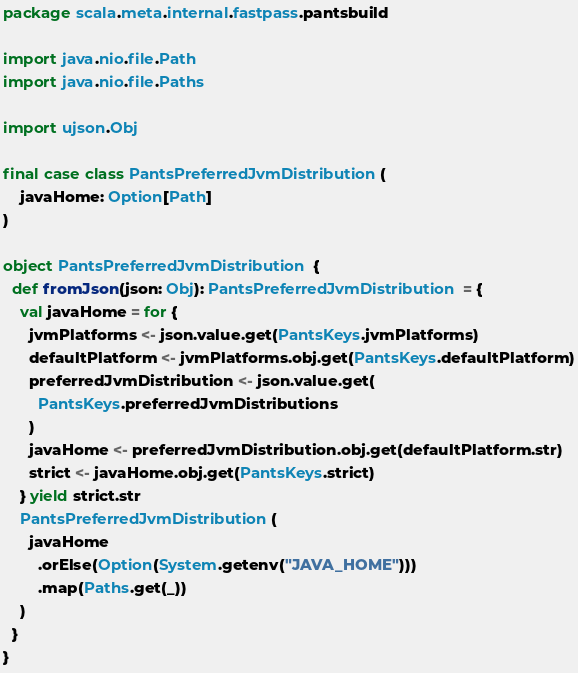<code> <loc_0><loc_0><loc_500><loc_500><_Scala_>package scala.meta.internal.fastpass.pantsbuild

import java.nio.file.Path
import java.nio.file.Paths

import ujson.Obj

final case class PantsPreferredJvmDistribution(
    javaHome: Option[Path]
)

object PantsPreferredJvmDistribution {
  def fromJson(json: Obj): PantsPreferredJvmDistribution = {
    val javaHome = for {
      jvmPlatforms <- json.value.get(PantsKeys.jvmPlatforms)
      defaultPlatform <- jvmPlatforms.obj.get(PantsKeys.defaultPlatform)
      preferredJvmDistribution <- json.value.get(
        PantsKeys.preferredJvmDistributions
      )
      javaHome <- preferredJvmDistribution.obj.get(defaultPlatform.str)
      strict <- javaHome.obj.get(PantsKeys.strict)
    } yield strict.str
    PantsPreferredJvmDistribution(
      javaHome
        .orElse(Option(System.getenv("JAVA_HOME")))
        .map(Paths.get(_))
    )
  }
}
</code> 